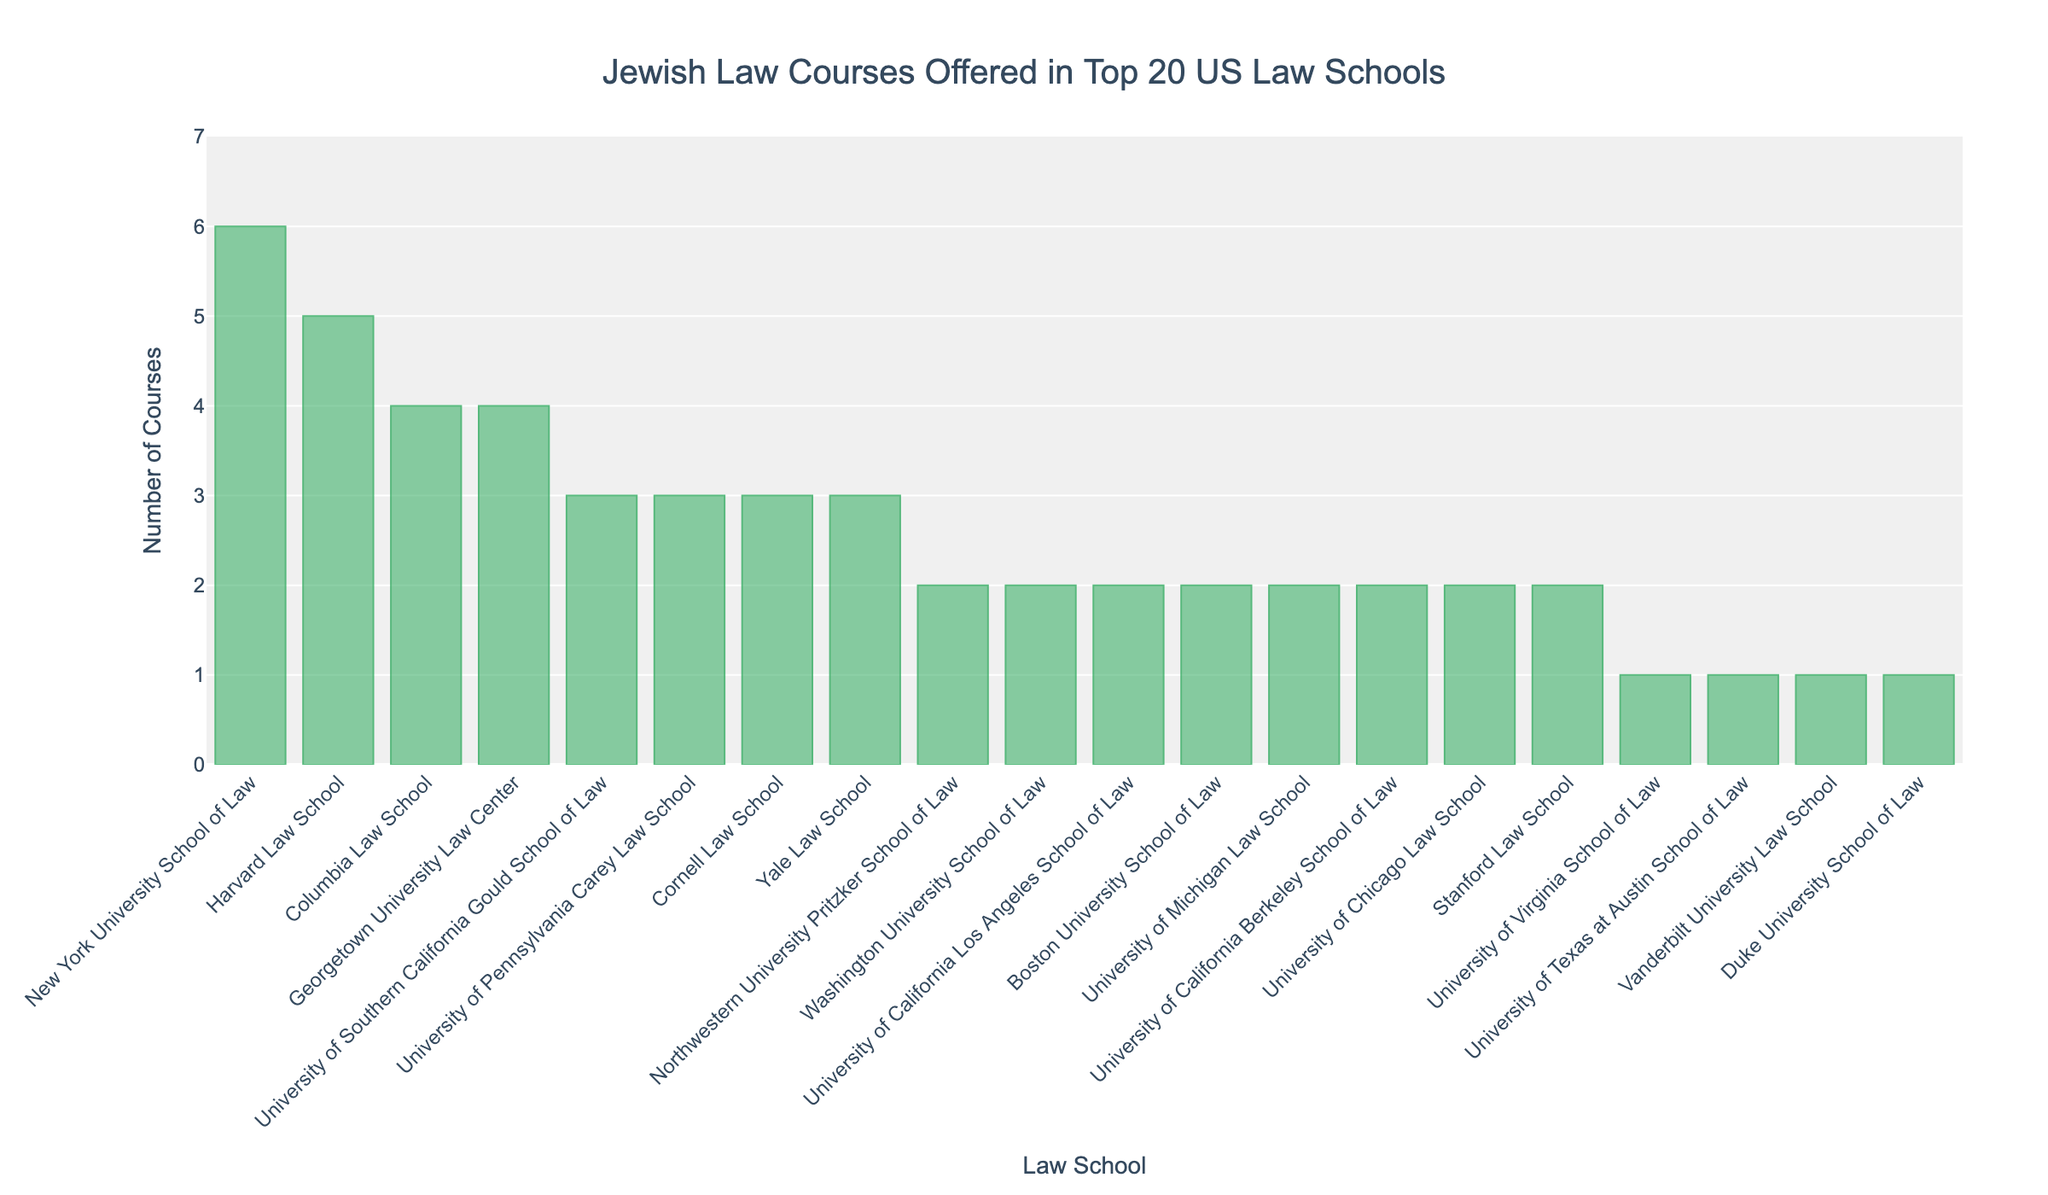What is the total number of Jewish Law courses offered by the top 3 schools with the highest number of courses? The top 3 schools with the highest number of courses are New York University School of Law (6), Harvard Law School (5), and Columbia Law School (4). Summing up these values gives 6 + 5 + 4 = 15.
Answer: 15 Which law school offers the least number of Jewish Law courses, and how many does it offer? The University of Virginia School of Law, Duke University School of Law, University of Texas at Austin School of Law, and Vanderbilt University Law School each offer 1 course. They are the lowest among the top 20 schools.
Answer: University of Virginia School of Law, Duke University School of Law, University of Texas at Austin School of Law, and Vanderbilt University Law School, 1 How many schools offer exactly 2 Jewish Law courses? To find the number of schools offering exactly 2 courses, count the bars with a height corresponding to the value 2. These schools are Stanford Law School, University of Chicago Law School, University of California Berkeley School of Law, University of Michigan Law School, Northwestern University Pritzker School of Law, University of California Los Angeles School of Law, Washington University School of Law, and Boston University School of Law. There are 8 such schools.
Answer: 8 Which schools offer more Jewish Law courses: Harvard Law School or Columbia Law School, and by how many? Harvard Law School offers 5 courses, and Columbia Law School offers 4. The difference is 5 - 4 = 1. Harvard Law School offers more by 1 course.
Answer: Harvard Law School, 1 What is the average number of Jewish Law courses offered by all 20 schools? To find the average, sum all the courses offered and divide by 20. The total number is 5 + 3 + 2 + 4 + 2 + 6 + 3 + 1 + 2 + 2 + 1 + 2 + 3 + 4 + 2 + 1 + 1 + 2 + 3 + 2 = 49. The average is 49 / 20 = 2.45.
Answer: 2.45 